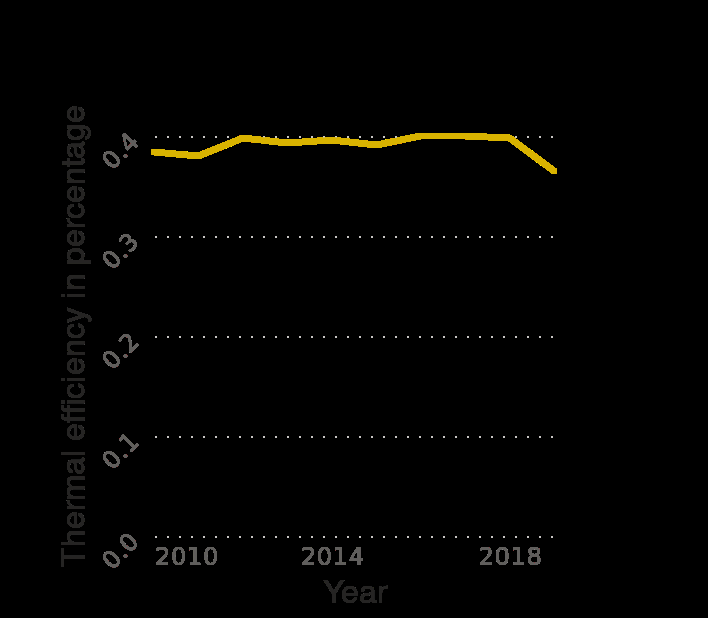<image>
Describe the following image in detail This line plot is called Thermal efficiency of nuclear power stations in the United Kingdom (UK) from 2010 to 2019 (in percentage). Year is measured along the x-axis. The y-axis measures Thermal efficiency in percentage as a linear scale with a minimum of 0.0 and a maximum of 0.4. What was the highest thermal efficiency recorded?  The highest thermal efficiency recorded was 0.4. Has the thermal efficiency increased or decreased over time?  The thermal efficiency initially increased and peaked at 0.4 but later experienced a dramatic decline in 2018. When was the thermal efficiency also at 0.4?  The thermal efficiency was also at 0.4 in 2011. What does the y-axis measure in this line plot?  The y-axis measures the thermal efficiency of nuclear power stations in percentage. 